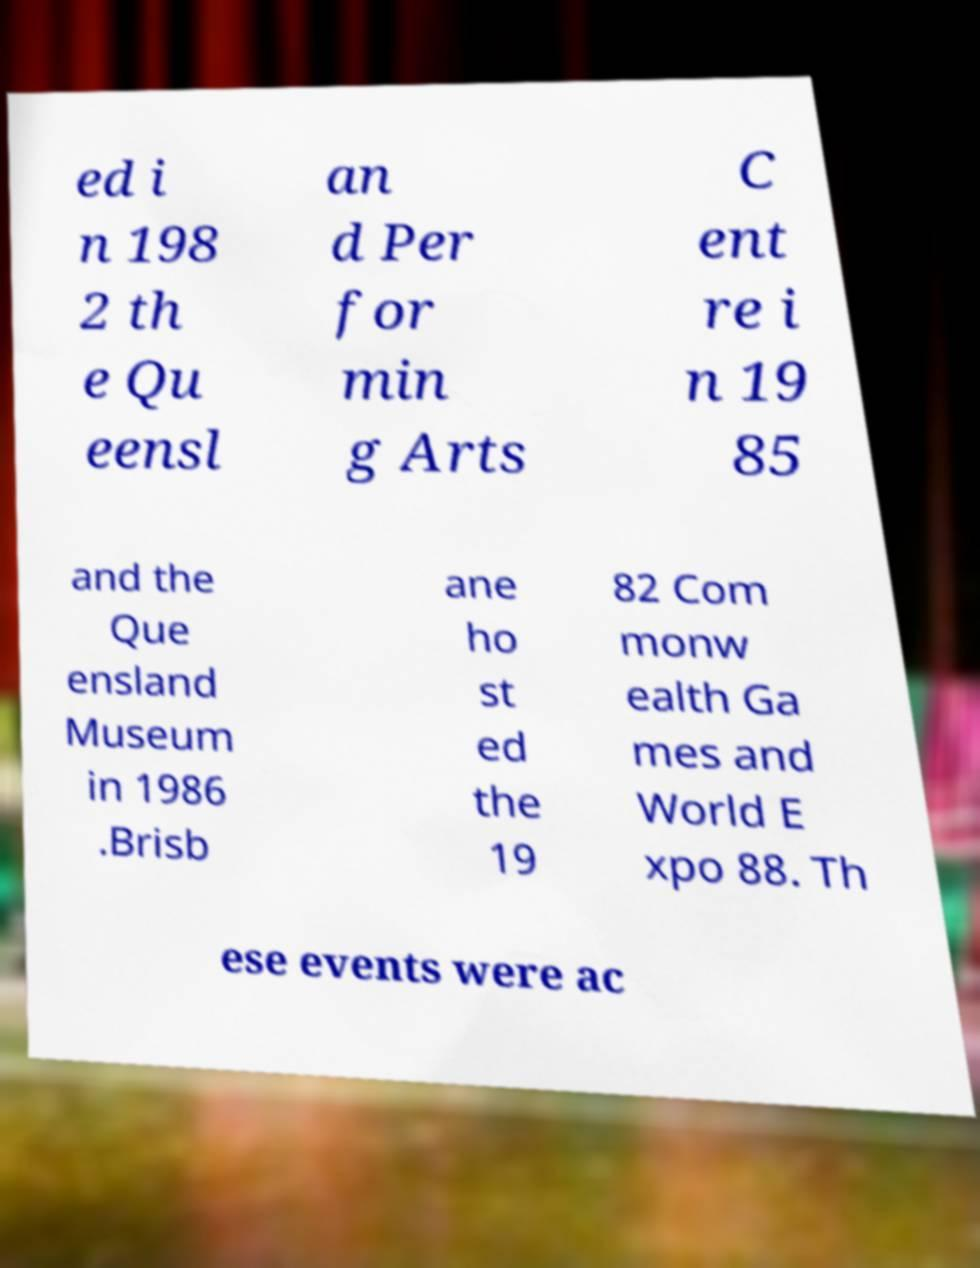For documentation purposes, I need the text within this image transcribed. Could you provide that? ed i n 198 2 th e Qu eensl an d Per for min g Arts C ent re i n 19 85 and the Que ensland Museum in 1986 .Brisb ane ho st ed the 19 82 Com monw ealth Ga mes and World E xpo 88. Th ese events were ac 